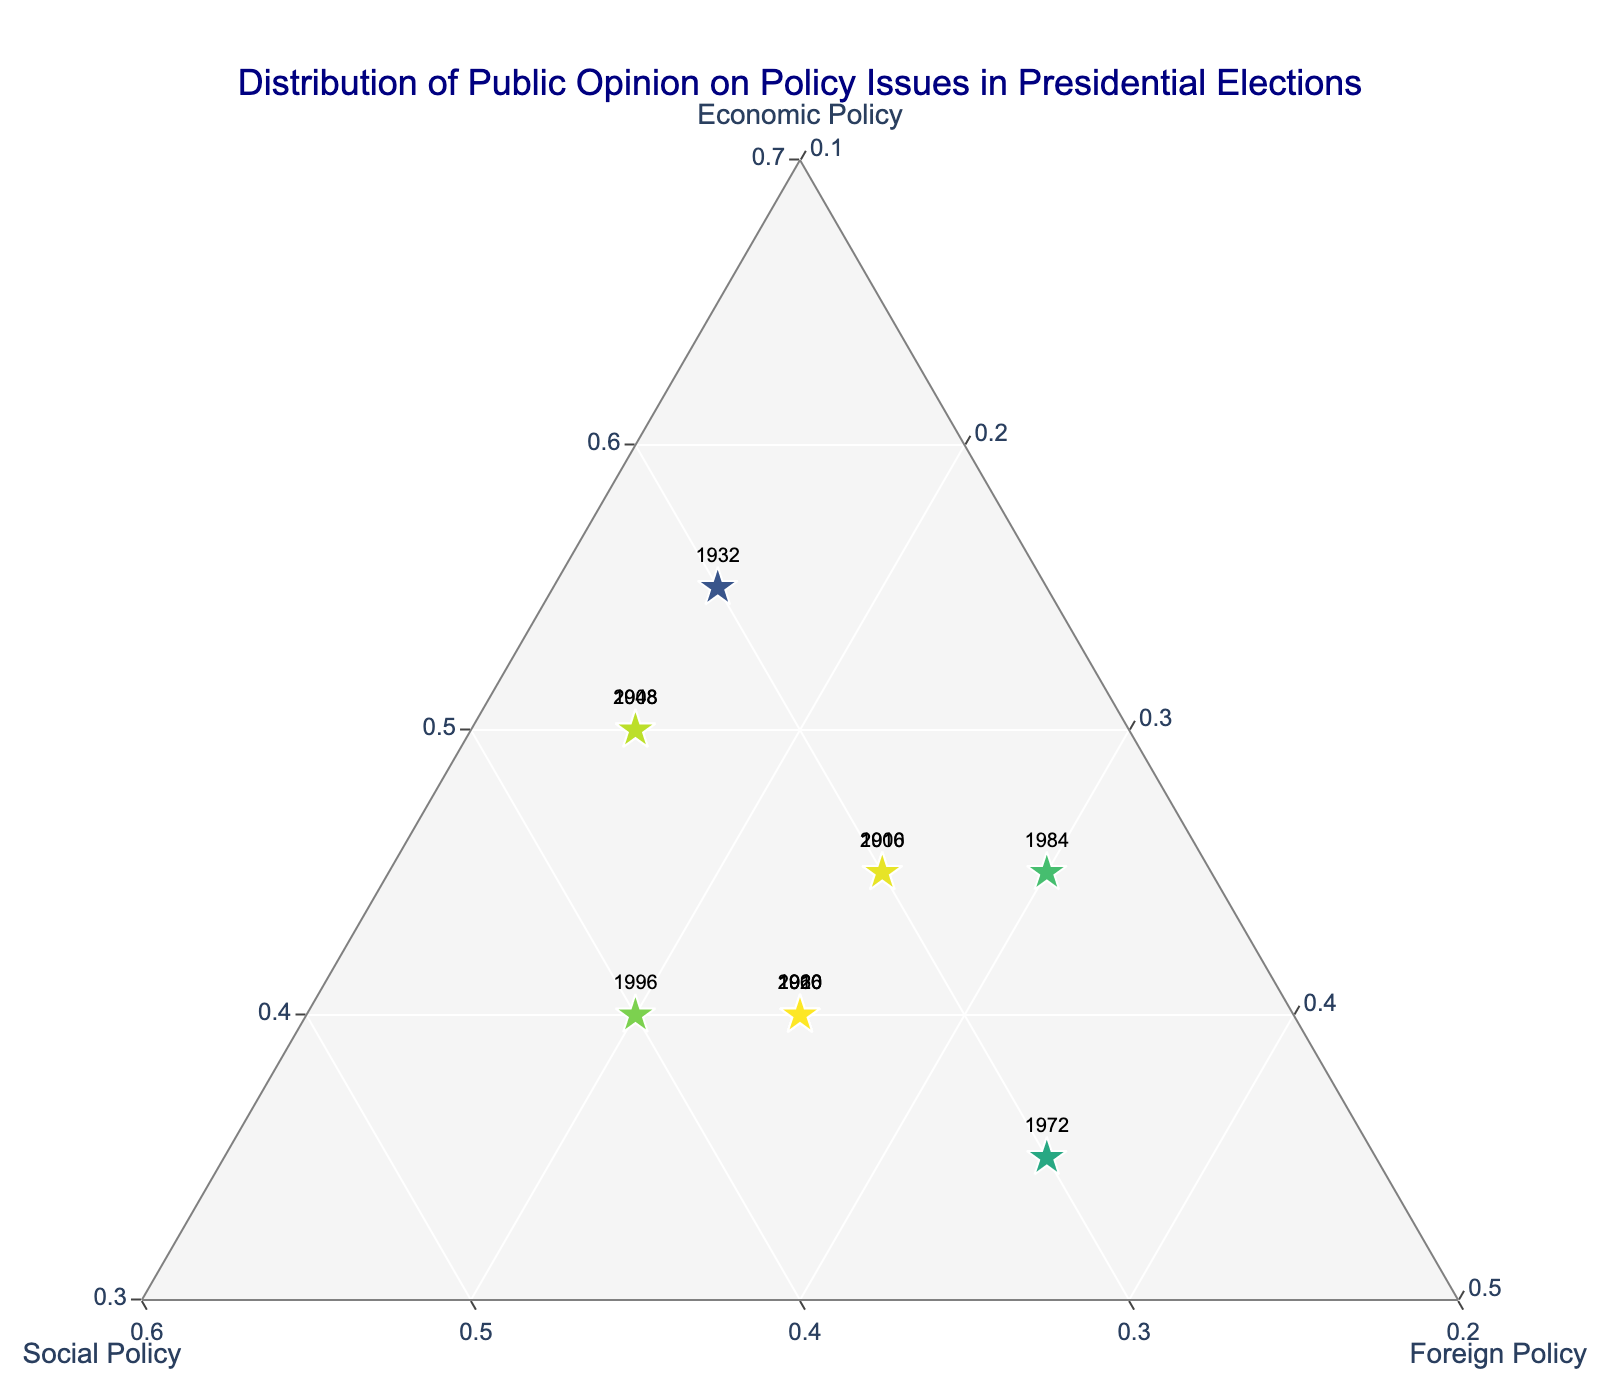What is the title of the figure? The title of a figure is usually displayed at the top and describes what the plot is about. By looking at the top center of the plot, we see the title "Distribution of Public Opinion on Policy Issues in Presidential Elections".
Answer: Distribution of Public Opinion on Policy Issues in Presidential Elections How are the axes of the ternary plot labeled? In a ternary plot, there are typically three axes that represent the components being measured. The axis labels are viewed as "Economic Policy", "Social Policy", and "Foreign Policy" from their respective directions.
Answer: Economic Policy, Social Policy, Foreign Policy Which election years have the highest focus on economic policy? To identify the years with the highest focus on economic policy, we look at the points positioned closest to the Economic Policy corner. These are the years with the highest percentage of economic policy focus, approximately 55%, are 1932 and 2008.
Answer: 1932, 2008 In which election year was the public opinion on social policy the most dominant? We need to find the point closest to the Social Policy corner since that would indicate the highest percentage. The year with around 40% focus on social policy is 1996.
Answer: 1996 How does the distribution of public opinion in 1972 compare to 2020? Look for the labeled markers for the years 1972 and 2020. 1972 is further away from Economic Policy, with around 35% Foreign Policy focus, while 2020 has a more balanced distribution among the three policies. Thus, in 1972, Foreign Policy is more dominant, whereas, in 2020, opinions are more evenly distributed.
Answer: 1972: More focus on Foreign Policy; 2020: More balanced What trend can be identified in the focus on economic policy from 1900 to 2020? To determine the trend, check the positioning of points associated with Economic Policy over the years. Early years like 1900 have lower Economic Policy percentages whereas recent years like 1932 and 2008 show higher percentages. Overall, Economic Policy focus has increased over the years.
Answer: Increased Which election years have the most balanced focus on economic, social, and foreign policies? Balanced focus would mean points that are closer to the center of the ternary plot. The year 1960, which is closer to the center, indicates a balanced focus with each policy making up roughly equal parts.
Answer: 1960 In which election year was there the least focus on foreign policy? Focus on foreign policy can be measured by the proximity of points to the Foreign Policy corner. The year 1932, positioned closer to Economic Policy and far from Foreign Policy, indicates the least focus, around 15%.
Answer: 1932 